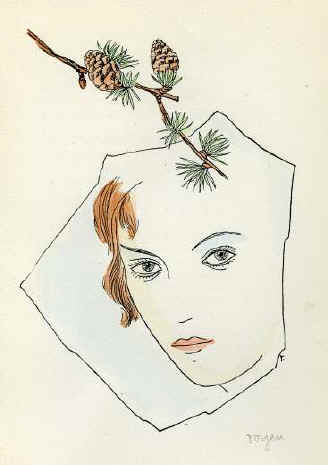How does the use of minimal colors contribute to the overall mood of the artwork? The artist's restrained use of color in this portrait, primarily employing shades of brown, green, and subtle pink against a light beige background, creates a serene and somewhat introspective mood. The minimal color palette directs the viewer's focus predominantly on the form and expression of the subject, emphasizing her features and the symbolic pine cones. This choice could be seen as a way to strip away distractions, allowing a more profound contemplation of the subject's expression and the surreal elements represented, fostering a more intimate connection between the viewer and the artwork. Does this stylistic choice affect the interpretation of the artwork? Yes, it certainly does. The subdued palette not only focuses attention on the central themes but also evokes a subtle emotional response that might not arise with a more vibrant color scheme. The choice of colors, or lack thereof, compels the viewer to reflect on the meaning behind the artwork more deeply, considering the symbolic elements and their possible interpretations without the distraction of a varied color spectrum. This might lead to a more personal and contemplative engagement with the image. 